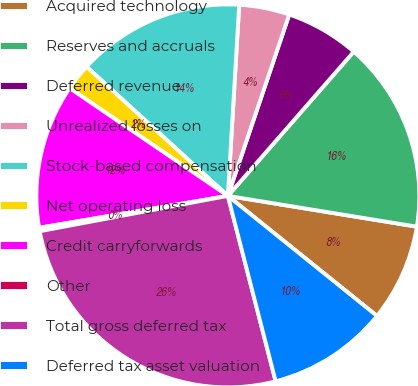Convert chart. <chart><loc_0><loc_0><loc_500><loc_500><pie_chart><fcel>Acquired technology<fcel>Reserves and accruals<fcel>Deferred revenue<fcel>Unrealized losses on<fcel>Stock-based compensation<fcel>Net operating loss<fcel>Credit carryforwards<fcel>Other<fcel>Total gross deferred tax<fcel>Deferred tax asset valuation<nl><fcel>8.22%<fcel>16.15%<fcel>6.23%<fcel>4.25%<fcel>14.16%<fcel>2.27%<fcel>12.18%<fcel>0.29%<fcel>26.06%<fcel>10.2%<nl></chart> 